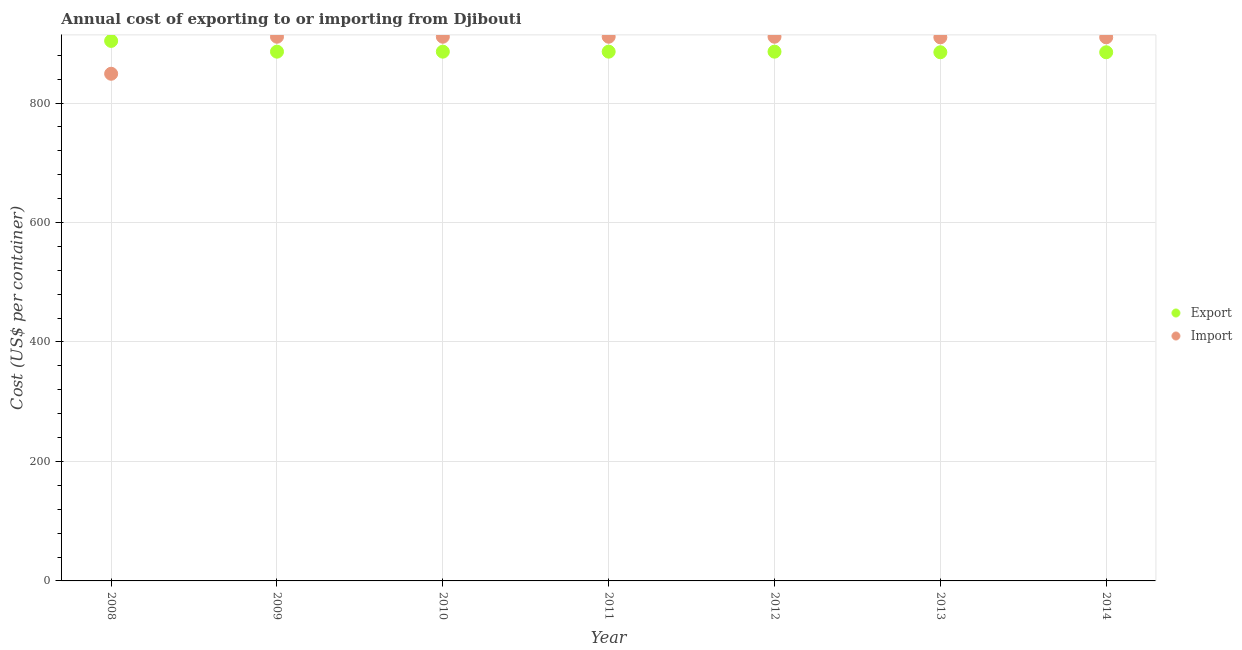Is the number of dotlines equal to the number of legend labels?
Provide a short and direct response. Yes. What is the import cost in 2012?
Provide a succinct answer. 911. Across all years, what is the maximum import cost?
Offer a very short reply. 911. Across all years, what is the minimum export cost?
Keep it short and to the point. 885. What is the total import cost in the graph?
Make the answer very short. 6313. What is the difference between the import cost in 2008 and that in 2010?
Your answer should be very brief. -62. What is the difference between the import cost in 2012 and the export cost in 2009?
Provide a succinct answer. 25. What is the average import cost per year?
Provide a succinct answer. 901.86. In the year 2011, what is the difference between the import cost and export cost?
Your response must be concise. 25. What is the ratio of the export cost in 2011 to that in 2014?
Your answer should be compact. 1. Is the difference between the import cost in 2009 and 2011 greater than the difference between the export cost in 2009 and 2011?
Your answer should be compact. No. What is the difference between the highest and the second highest export cost?
Your answer should be very brief. 18. What is the difference between the highest and the lowest export cost?
Your answer should be very brief. 19. In how many years, is the import cost greater than the average import cost taken over all years?
Offer a terse response. 6. Is the sum of the import cost in 2008 and 2010 greater than the maximum export cost across all years?
Ensure brevity in your answer.  Yes. Are the values on the major ticks of Y-axis written in scientific E-notation?
Offer a very short reply. No. Does the graph contain any zero values?
Your answer should be very brief. No. Does the graph contain grids?
Provide a short and direct response. Yes. How are the legend labels stacked?
Your response must be concise. Vertical. What is the title of the graph?
Your response must be concise. Annual cost of exporting to or importing from Djibouti. Does "Net National savings" appear as one of the legend labels in the graph?
Provide a short and direct response. No. What is the label or title of the Y-axis?
Provide a short and direct response. Cost (US$ per container). What is the Cost (US$ per container) of Export in 2008?
Offer a terse response. 904. What is the Cost (US$ per container) of Import in 2008?
Provide a short and direct response. 849. What is the Cost (US$ per container) in Export in 2009?
Provide a succinct answer. 886. What is the Cost (US$ per container) of Import in 2009?
Provide a succinct answer. 911. What is the Cost (US$ per container) of Export in 2010?
Keep it short and to the point. 886. What is the Cost (US$ per container) of Import in 2010?
Ensure brevity in your answer.  911. What is the Cost (US$ per container) in Export in 2011?
Give a very brief answer. 886. What is the Cost (US$ per container) in Import in 2011?
Ensure brevity in your answer.  911. What is the Cost (US$ per container) of Export in 2012?
Provide a short and direct response. 886. What is the Cost (US$ per container) in Import in 2012?
Provide a short and direct response. 911. What is the Cost (US$ per container) of Export in 2013?
Your response must be concise. 885. What is the Cost (US$ per container) of Import in 2013?
Make the answer very short. 910. What is the Cost (US$ per container) of Export in 2014?
Your response must be concise. 885. What is the Cost (US$ per container) in Import in 2014?
Your answer should be compact. 910. Across all years, what is the maximum Cost (US$ per container) of Export?
Provide a short and direct response. 904. Across all years, what is the maximum Cost (US$ per container) of Import?
Your answer should be very brief. 911. Across all years, what is the minimum Cost (US$ per container) of Export?
Ensure brevity in your answer.  885. Across all years, what is the minimum Cost (US$ per container) in Import?
Your answer should be very brief. 849. What is the total Cost (US$ per container) in Export in the graph?
Your response must be concise. 6218. What is the total Cost (US$ per container) in Import in the graph?
Offer a terse response. 6313. What is the difference between the Cost (US$ per container) of Export in 2008 and that in 2009?
Your response must be concise. 18. What is the difference between the Cost (US$ per container) in Import in 2008 and that in 2009?
Give a very brief answer. -62. What is the difference between the Cost (US$ per container) in Import in 2008 and that in 2010?
Make the answer very short. -62. What is the difference between the Cost (US$ per container) of Export in 2008 and that in 2011?
Keep it short and to the point. 18. What is the difference between the Cost (US$ per container) in Import in 2008 and that in 2011?
Offer a terse response. -62. What is the difference between the Cost (US$ per container) of Export in 2008 and that in 2012?
Provide a succinct answer. 18. What is the difference between the Cost (US$ per container) of Import in 2008 and that in 2012?
Ensure brevity in your answer.  -62. What is the difference between the Cost (US$ per container) of Import in 2008 and that in 2013?
Your response must be concise. -61. What is the difference between the Cost (US$ per container) in Import in 2008 and that in 2014?
Give a very brief answer. -61. What is the difference between the Cost (US$ per container) of Export in 2009 and that in 2010?
Ensure brevity in your answer.  0. What is the difference between the Cost (US$ per container) in Export in 2009 and that in 2012?
Give a very brief answer. 0. What is the difference between the Cost (US$ per container) in Import in 2009 and that in 2012?
Keep it short and to the point. 0. What is the difference between the Cost (US$ per container) in Export in 2009 and that in 2014?
Offer a very short reply. 1. What is the difference between the Cost (US$ per container) of Import in 2009 and that in 2014?
Offer a terse response. 1. What is the difference between the Cost (US$ per container) in Import in 2010 and that in 2011?
Give a very brief answer. 0. What is the difference between the Cost (US$ per container) of Export in 2010 and that in 2012?
Provide a succinct answer. 0. What is the difference between the Cost (US$ per container) of Import in 2010 and that in 2012?
Provide a short and direct response. 0. What is the difference between the Cost (US$ per container) of Import in 2010 and that in 2013?
Make the answer very short. 1. What is the difference between the Cost (US$ per container) of Import in 2011 and that in 2013?
Your answer should be compact. 1. What is the difference between the Cost (US$ per container) of Export in 2012 and that in 2014?
Provide a succinct answer. 1. What is the difference between the Cost (US$ per container) of Export in 2013 and that in 2014?
Make the answer very short. 0. What is the difference between the Cost (US$ per container) of Import in 2013 and that in 2014?
Provide a short and direct response. 0. What is the difference between the Cost (US$ per container) of Export in 2008 and the Cost (US$ per container) of Import in 2009?
Your answer should be very brief. -7. What is the difference between the Cost (US$ per container) of Export in 2008 and the Cost (US$ per container) of Import in 2010?
Offer a terse response. -7. What is the difference between the Cost (US$ per container) in Export in 2008 and the Cost (US$ per container) in Import in 2011?
Offer a terse response. -7. What is the difference between the Cost (US$ per container) in Export in 2008 and the Cost (US$ per container) in Import in 2012?
Your response must be concise. -7. What is the difference between the Cost (US$ per container) of Export in 2008 and the Cost (US$ per container) of Import in 2013?
Provide a succinct answer. -6. What is the difference between the Cost (US$ per container) of Export in 2008 and the Cost (US$ per container) of Import in 2014?
Make the answer very short. -6. What is the difference between the Cost (US$ per container) in Export in 2009 and the Cost (US$ per container) in Import in 2010?
Keep it short and to the point. -25. What is the difference between the Cost (US$ per container) in Export in 2010 and the Cost (US$ per container) in Import in 2012?
Offer a very short reply. -25. What is the difference between the Cost (US$ per container) of Export in 2011 and the Cost (US$ per container) of Import in 2012?
Offer a very short reply. -25. What is the difference between the Cost (US$ per container) of Export in 2011 and the Cost (US$ per container) of Import in 2013?
Make the answer very short. -24. What is the difference between the Cost (US$ per container) of Export in 2011 and the Cost (US$ per container) of Import in 2014?
Give a very brief answer. -24. What is the difference between the Cost (US$ per container) in Export in 2012 and the Cost (US$ per container) in Import in 2013?
Ensure brevity in your answer.  -24. What is the difference between the Cost (US$ per container) in Export in 2013 and the Cost (US$ per container) in Import in 2014?
Provide a short and direct response. -25. What is the average Cost (US$ per container) of Export per year?
Ensure brevity in your answer.  888.29. What is the average Cost (US$ per container) of Import per year?
Offer a very short reply. 901.86. In the year 2008, what is the difference between the Cost (US$ per container) in Export and Cost (US$ per container) in Import?
Make the answer very short. 55. In the year 2010, what is the difference between the Cost (US$ per container) of Export and Cost (US$ per container) of Import?
Provide a succinct answer. -25. In the year 2011, what is the difference between the Cost (US$ per container) of Export and Cost (US$ per container) of Import?
Provide a succinct answer. -25. In the year 2012, what is the difference between the Cost (US$ per container) of Export and Cost (US$ per container) of Import?
Offer a terse response. -25. In the year 2013, what is the difference between the Cost (US$ per container) in Export and Cost (US$ per container) in Import?
Give a very brief answer. -25. In the year 2014, what is the difference between the Cost (US$ per container) of Export and Cost (US$ per container) of Import?
Give a very brief answer. -25. What is the ratio of the Cost (US$ per container) of Export in 2008 to that in 2009?
Offer a terse response. 1.02. What is the ratio of the Cost (US$ per container) of Import in 2008 to that in 2009?
Your answer should be compact. 0.93. What is the ratio of the Cost (US$ per container) in Export in 2008 to that in 2010?
Keep it short and to the point. 1.02. What is the ratio of the Cost (US$ per container) in Import in 2008 to that in 2010?
Provide a succinct answer. 0.93. What is the ratio of the Cost (US$ per container) of Export in 2008 to that in 2011?
Make the answer very short. 1.02. What is the ratio of the Cost (US$ per container) in Import in 2008 to that in 2011?
Make the answer very short. 0.93. What is the ratio of the Cost (US$ per container) of Export in 2008 to that in 2012?
Give a very brief answer. 1.02. What is the ratio of the Cost (US$ per container) of Import in 2008 to that in 2012?
Ensure brevity in your answer.  0.93. What is the ratio of the Cost (US$ per container) in Export in 2008 to that in 2013?
Give a very brief answer. 1.02. What is the ratio of the Cost (US$ per container) in Import in 2008 to that in 2013?
Your answer should be very brief. 0.93. What is the ratio of the Cost (US$ per container) in Export in 2008 to that in 2014?
Keep it short and to the point. 1.02. What is the ratio of the Cost (US$ per container) in Import in 2008 to that in 2014?
Keep it short and to the point. 0.93. What is the ratio of the Cost (US$ per container) in Export in 2009 to that in 2011?
Your response must be concise. 1. What is the ratio of the Cost (US$ per container) in Import in 2009 to that in 2011?
Give a very brief answer. 1. What is the ratio of the Cost (US$ per container) of Export in 2009 to that in 2012?
Your answer should be compact. 1. What is the ratio of the Cost (US$ per container) in Export in 2009 to that in 2014?
Offer a terse response. 1. What is the ratio of the Cost (US$ per container) in Export in 2010 to that in 2011?
Offer a terse response. 1. What is the ratio of the Cost (US$ per container) of Import in 2010 to that in 2011?
Your answer should be very brief. 1. What is the ratio of the Cost (US$ per container) in Export in 2010 to that in 2012?
Give a very brief answer. 1. What is the ratio of the Cost (US$ per container) of Export in 2010 to that in 2013?
Keep it short and to the point. 1. What is the ratio of the Cost (US$ per container) in Import in 2010 to that in 2014?
Your answer should be very brief. 1. What is the ratio of the Cost (US$ per container) of Import in 2011 to that in 2012?
Provide a short and direct response. 1. What is the ratio of the Cost (US$ per container) of Export in 2011 to that in 2014?
Offer a very short reply. 1. What is the ratio of the Cost (US$ per container) of Export in 2012 to that in 2013?
Provide a succinct answer. 1. What is the ratio of the Cost (US$ per container) of Import in 2012 to that in 2014?
Provide a short and direct response. 1. What is the ratio of the Cost (US$ per container) of Export in 2013 to that in 2014?
Make the answer very short. 1. What is the ratio of the Cost (US$ per container) of Import in 2013 to that in 2014?
Offer a very short reply. 1. What is the difference between the highest and the second highest Cost (US$ per container) of Export?
Offer a terse response. 18. 